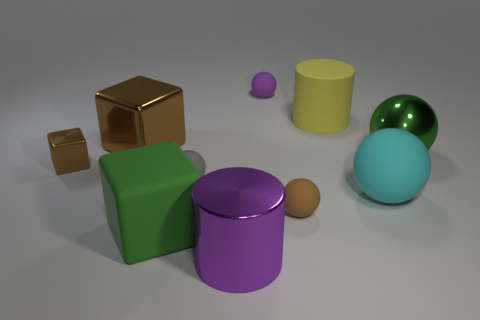What are the different shapes present in the image, and how do they compare in size? The image features a collection of geometric shapes, including spheres, cylinders, and cubes. Size comparison reveals that the cubes are of two different sizes, the cylinders vary from wide and short to narrow and tall, and the spheres also range in size from small to large, providing a diverse representation of dimensions. 